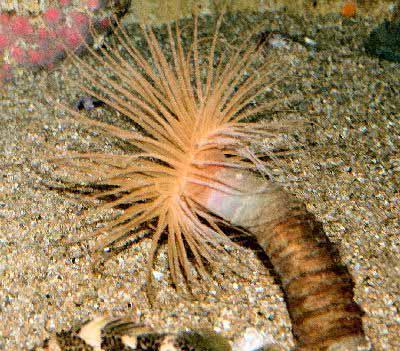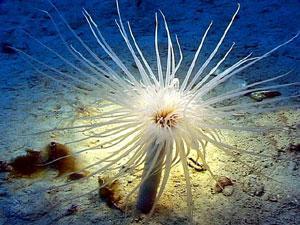The first image is the image on the left, the second image is the image on the right. For the images displayed, is the sentence "Each image contains at least one prominent anemone with glowing bluish tint, but the lefthand anemone has a white center and deeper blue around the edges." factually correct? Answer yes or no. No. 